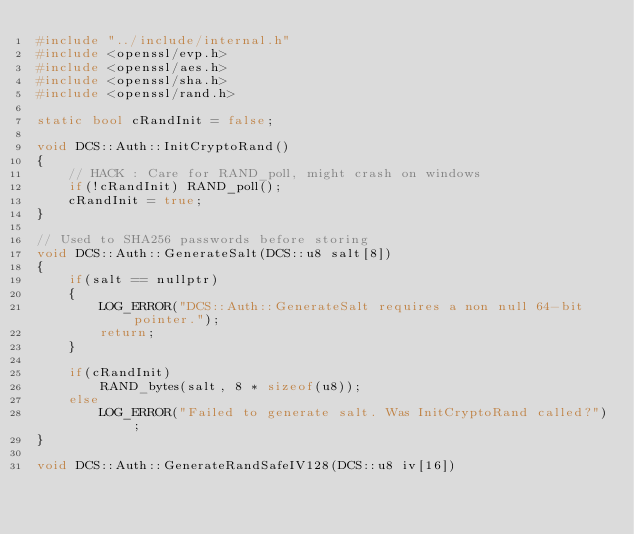Convert code to text. <code><loc_0><loc_0><loc_500><loc_500><_C++_>#include "../include/internal.h"
#include <openssl/evp.h>
#include <openssl/aes.h>
#include <openssl/sha.h>
#include <openssl/rand.h>

static bool cRandInit = false;

void DCS::Auth::InitCryptoRand()
{
    // HACK : Care for RAND_poll, might crash on windows
    if(!cRandInit) RAND_poll();
    cRandInit = true;
}

// Used to SHA256 passwords before storing
void DCS::Auth::GenerateSalt(DCS::u8 salt[8])
{
    if(salt == nullptr)
    {
        LOG_ERROR("DCS::Auth::GenerateSalt requires a non null 64-bit pointer.");
        return;
    }

    if(cRandInit)
        RAND_bytes(salt, 8 * sizeof(u8));
    else
        LOG_ERROR("Failed to generate salt. Was InitCryptoRand called?");
}

void DCS::Auth::GenerateRandSafeIV128(DCS::u8 iv[16])</code> 